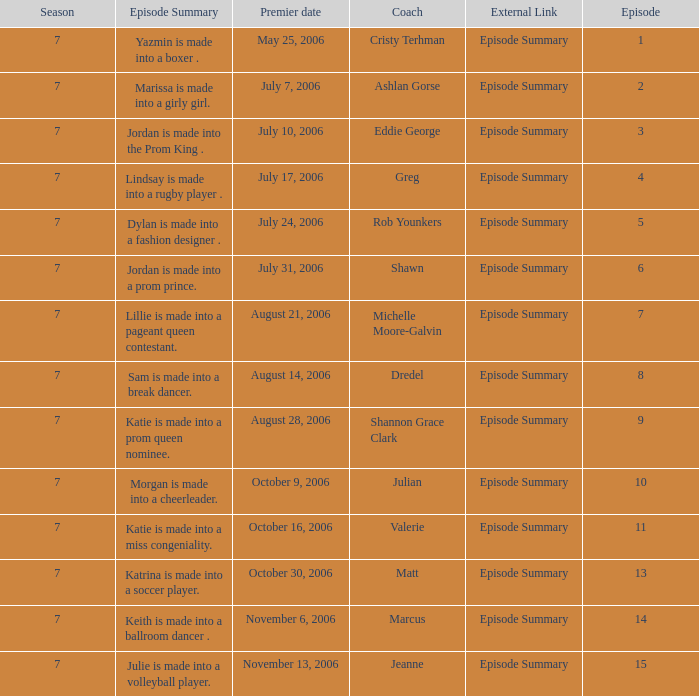How many episodes have a premier date of july 24, 2006 1.0. 